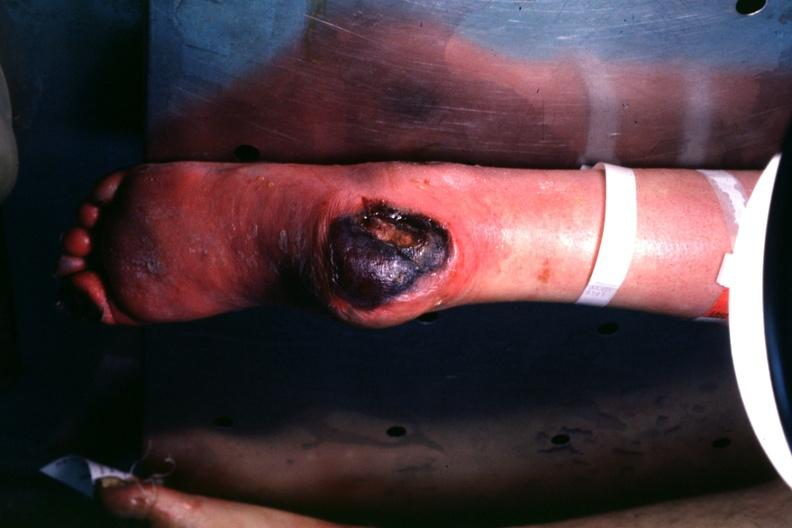does siamese twins show good example of this diabetic lesion va.?
Answer the question using a single word or phrase. No 